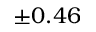<formula> <loc_0><loc_0><loc_500><loc_500>\pm 0 . 4 6</formula> 